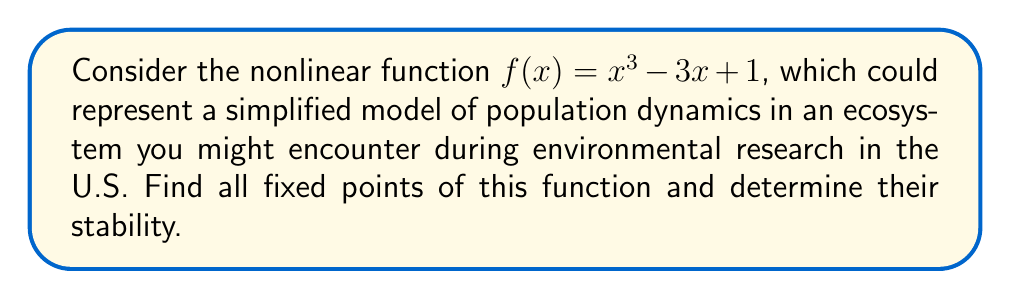Show me your answer to this math problem. 1) First, let's find the fixed points. Fixed points occur when $f(x) = x$. So, we need to solve:

   $x^3 - 3x + 1 = x$

2) Rearranging the equation:

   $x^3 - 4x + 1 = 0$

3) This is a cubic equation. One solution is obvious: $x = 1$. We can factor out $(x - 1)$:

   $(x - 1)(x^2 + x - 1) = 0$

4) Using the quadratic formula on $x^2 + x - 1 = 0$, we get:

   $x = \frac{-1 \pm \sqrt{1^2 - 4(1)(-1)}}{2(1)} = \frac{-1 \pm \sqrt{5}}{2}$

5) Therefore, the fixed points are:

   $x_1 = 1$, $x_2 = \frac{-1 + \sqrt{5}}{2}$, $x_3 = \frac{-1 - \sqrt{5}}{2}$

6) To determine stability, we need to find $f'(x)$ and evaluate it at each fixed point:

   $f'(x) = 3x^2 - 3$

7) For $x_1 = 1$:
   $f'(1) = 3(1)^2 - 3 = 0$
   This is a neutral fixed point.

8) For $x_2 = \frac{-1 + \sqrt{5}}{2}$:
   $f'(\frac{-1 + \sqrt{5}}{2}) = 3(\frac{-1 + \sqrt{5}}{2})^2 - 3 = \frac{3(\sqrt{5} - 1)}{2} > 0$
   This is an unstable fixed point.

9) For $x_3 = \frac{-1 - \sqrt{5}}{2}$:
   $f'(\frac{-1 - \sqrt{5}}{2}) = 3(\frac{-1 - \sqrt{5}}{2})^2 - 3 = \frac{3(-\sqrt{5} - 1)}{2} < 0$
   This is a stable fixed point.
Answer: Fixed points: $x_1 = 1$ (neutral), $x_2 = \frac{-1 + \sqrt{5}}{2}$ (unstable), $x_3 = \frac{-1 - \sqrt{5}}{2}$ (stable) 